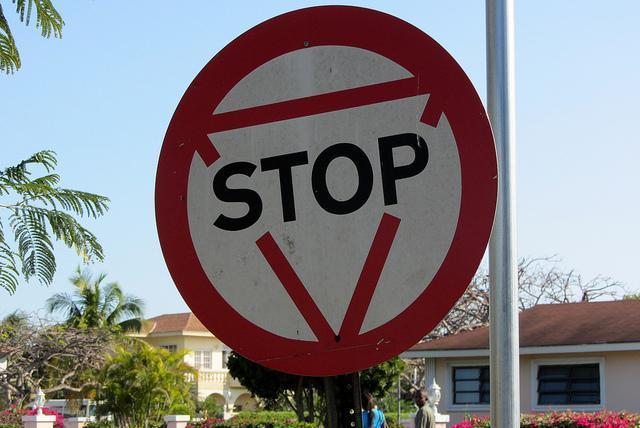How many leather couches are there in the living room?
Give a very brief answer. 0. 